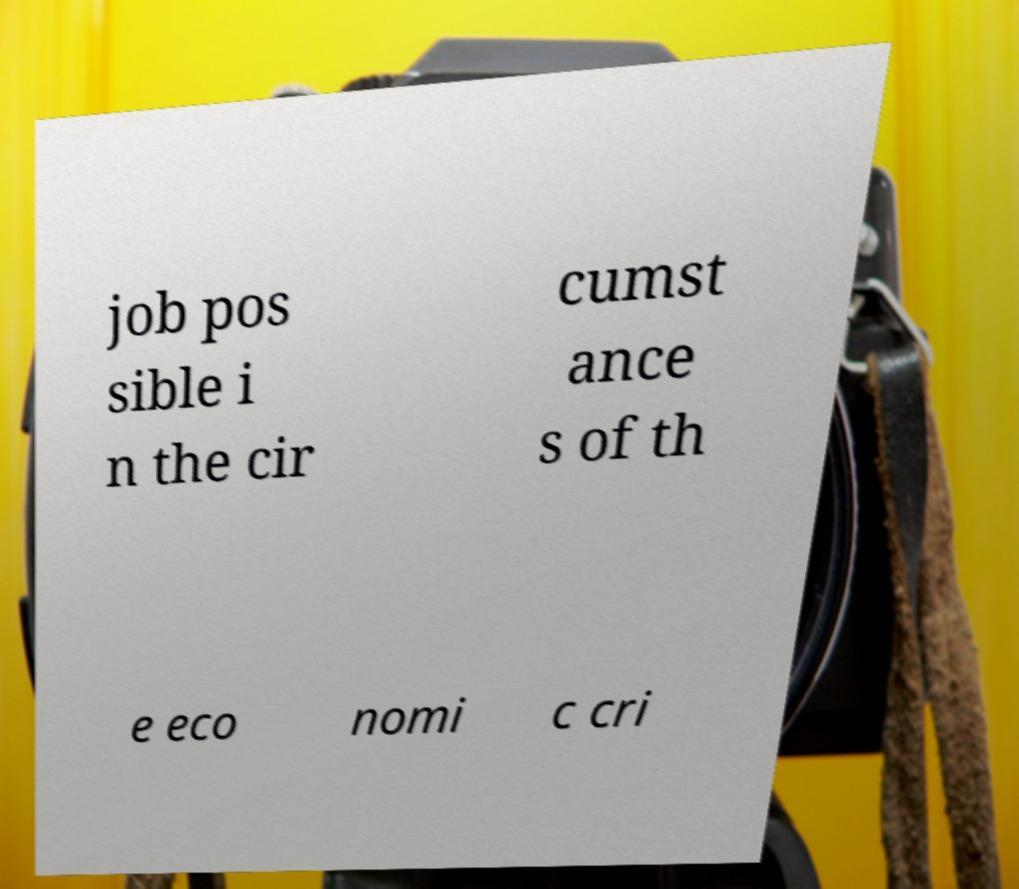Could you extract and type out the text from this image? job pos sible i n the cir cumst ance s of th e eco nomi c cri 